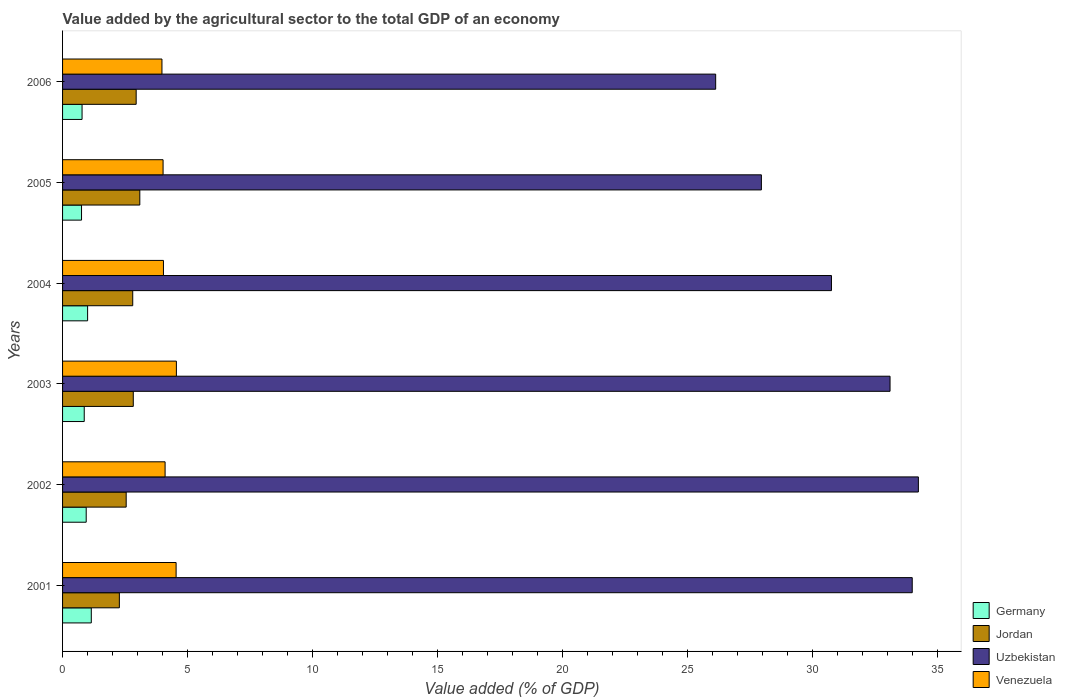How many different coloured bars are there?
Offer a very short reply. 4. Are the number of bars on each tick of the Y-axis equal?
Your answer should be compact. Yes. In how many cases, is the number of bars for a given year not equal to the number of legend labels?
Provide a succinct answer. 0. What is the value added by the agricultural sector to the total GDP in Germany in 2004?
Ensure brevity in your answer.  1. Across all years, what is the maximum value added by the agricultural sector to the total GDP in Jordan?
Make the answer very short. 3.09. Across all years, what is the minimum value added by the agricultural sector to the total GDP in Germany?
Your answer should be compact. 0.76. What is the total value added by the agricultural sector to the total GDP in Uzbekistan in the graph?
Offer a terse response. 186.26. What is the difference between the value added by the agricultural sector to the total GDP in Uzbekistan in 2002 and that in 2004?
Make the answer very short. 3.48. What is the difference between the value added by the agricultural sector to the total GDP in Uzbekistan in 2005 and the value added by the agricultural sector to the total GDP in Germany in 2003?
Offer a very short reply. 27.1. What is the average value added by the agricultural sector to the total GDP in Germany per year?
Your answer should be compact. 0.92. In the year 2004, what is the difference between the value added by the agricultural sector to the total GDP in Jordan and value added by the agricultural sector to the total GDP in Venezuela?
Your answer should be compact. -1.23. What is the ratio of the value added by the agricultural sector to the total GDP in Uzbekistan in 2005 to that in 2006?
Offer a very short reply. 1.07. Is the value added by the agricultural sector to the total GDP in Uzbekistan in 2001 less than that in 2002?
Offer a very short reply. Yes. What is the difference between the highest and the second highest value added by the agricultural sector to the total GDP in Venezuela?
Keep it short and to the point. 0.01. What is the difference between the highest and the lowest value added by the agricultural sector to the total GDP in Germany?
Offer a terse response. 0.39. How many bars are there?
Offer a very short reply. 24. Are all the bars in the graph horizontal?
Offer a terse response. Yes. How many years are there in the graph?
Give a very brief answer. 6. Does the graph contain any zero values?
Your response must be concise. No. Does the graph contain grids?
Your answer should be compact. No. Where does the legend appear in the graph?
Ensure brevity in your answer.  Bottom right. How many legend labels are there?
Provide a short and direct response. 4. How are the legend labels stacked?
Offer a very short reply. Vertical. What is the title of the graph?
Provide a succinct answer. Value added by the agricultural sector to the total GDP of an economy. What is the label or title of the X-axis?
Give a very brief answer. Value added (% of GDP). What is the Value added (% of GDP) of Germany in 2001?
Keep it short and to the point. 1.15. What is the Value added (% of GDP) of Jordan in 2001?
Provide a short and direct response. 2.27. What is the Value added (% of GDP) of Uzbekistan in 2001?
Ensure brevity in your answer.  34.01. What is the Value added (% of GDP) in Venezuela in 2001?
Provide a short and direct response. 4.54. What is the Value added (% of GDP) of Germany in 2002?
Provide a short and direct response. 0.95. What is the Value added (% of GDP) of Jordan in 2002?
Offer a terse response. 2.55. What is the Value added (% of GDP) of Uzbekistan in 2002?
Offer a terse response. 34.25. What is the Value added (% of GDP) in Venezuela in 2002?
Your answer should be very brief. 4.1. What is the Value added (% of GDP) in Germany in 2003?
Keep it short and to the point. 0.87. What is the Value added (% of GDP) of Jordan in 2003?
Your answer should be very brief. 2.83. What is the Value added (% of GDP) of Uzbekistan in 2003?
Ensure brevity in your answer.  33.12. What is the Value added (% of GDP) of Venezuela in 2003?
Your response must be concise. 4.56. What is the Value added (% of GDP) of Germany in 2004?
Provide a succinct answer. 1. What is the Value added (% of GDP) in Jordan in 2004?
Your answer should be very brief. 2.81. What is the Value added (% of GDP) of Uzbekistan in 2004?
Give a very brief answer. 30.77. What is the Value added (% of GDP) of Venezuela in 2004?
Keep it short and to the point. 4.04. What is the Value added (% of GDP) in Germany in 2005?
Provide a short and direct response. 0.76. What is the Value added (% of GDP) of Jordan in 2005?
Provide a short and direct response. 3.09. What is the Value added (% of GDP) in Uzbekistan in 2005?
Your answer should be very brief. 27.97. What is the Value added (% of GDP) of Venezuela in 2005?
Your answer should be very brief. 4.02. What is the Value added (% of GDP) of Germany in 2006?
Offer a terse response. 0.78. What is the Value added (% of GDP) of Jordan in 2006?
Give a very brief answer. 2.95. What is the Value added (% of GDP) in Uzbekistan in 2006?
Offer a terse response. 26.14. What is the Value added (% of GDP) in Venezuela in 2006?
Offer a terse response. 3.98. Across all years, what is the maximum Value added (% of GDP) in Germany?
Your answer should be compact. 1.15. Across all years, what is the maximum Value added (% of GDP) of Jordan?
Offer a terse response. 3.09. Across all years, what is the maximum Value added (% of GDP) of Uzbekistan?
Offer a terse response. 34.25. Across all years, what is the maximum Value added (% of GDP) of Venezuela?
Your answer should be compact. 4.56. Across all years, what is the minimum Value added (% of GDP) of Germany?
Offer a terse response. 0.76. Across all years, what is the minimum Value added (% of GDP) in Jordan?
Provide a short and direct response. 2.27. Across all years, what is the minimum Value added (% of GDP) in Uzbekistan?
Offer a terse response. 26.14. Across all years, what is the minimum Value added (% of GDP) of Venezuela?
Provide a succinct answer. 3.98. What is the total Value added (% of GDP) of Germany in the graph?
Make the answer very short. 5.5. What is the total Value added (% of GDP) in Jordan in the graph?
Provide a succinct answer. 16.5. What is the total Value added (% of GDP) in Uzbekistan in the graph?
Keep it short and to the point. 186.26. What is the total Value added (% of GDP) of Venezuela in the graph?
Provide a succinct answer. 25.24. What is the difference between the Value added (% of GDP) in Germany in 2001 and that in 2002?
Give a very brief answer. 0.2. What is the difference between the Value added (% of GDP) of Jordan in 2001 and that in 2002?
Provide a succinct answer. -0.27. What is the difference between the Value added (% of GDP) in Uzbekistan in 2001 and that in 2002?
Your answer should be compact. -0.25. What is the difference between the Value added (% of GDP) of Venezuela in 2001 and that in 2002?
Your answer should be very brief. 0.44. What is the difference between the Value added (% of GDP) of Germany in 2001 and that in 2003?
Your answer should be very brief. 0.28. What is the difference between the Value added (% of GDP) of Jordan in 2001 and that in 2003?
Provide a short and direct response. -0.56. What is the difference between the Value added (% of GDP) of Uzbekistan in 2001 and that in 2003?
Provide a short and direct response. 0.89. What is the difference between the Value added (% of GDP) of Venezuela in 2001 and that in 2003?
Give a very brief answer. -0.01. What is the difference between the Value added (% of GDP) in Germany in 2001 and that in 2004?
Provide a short and direct response. 0.15. What is the difference between the Value added (% of GDP) of Jordan in 2001 and that in 2004?
Your response must be concise. -0.54. What is the difference between the Value added (% of GDP) of Uzbekistan in 2001 and that in 2004?
Give a very brief answer. 3.23. What is the difference between the Value added (% of GDP) of Venezuela in 2001 and that in 2004?
Your answer should be very brief. 0.51. What is the difference between the Value added (% of GDP) in Germany in 2001 and that in 2005?
Offer a very short reply. 0.39. What is the difference between the Value added (% of GDP) in Jordan in 2001 and that in 2005?
Ensure brevity in your answer.  -0.82. What is the difference between the Value added (% of GDP) in Uzbekistan in 2001 and that in 2005?
Provide a succinct answer. 6.04. What is the difference between the Value added (% of GDP) of Venezuela in 2001 and that in 2005?
Keep it short and to the point. 0.52. What is the difference between the Value added (% of GDP) in Germany in 2001 and that in 2006?
Your response must be concise. 0.37. What is the difference between the Value added (% of GDP) of Jordan in 2001 and that in 2006?
Give a very brief answer. -0.67. What is the difference between the Value added (% of GDP) in Uzbekistan in 2001 and that in 2006?
Provide a short and direct response. 7.87. What is the difference between the Value added (% of GDP) in Venezuela in 2001 and that in 2006?
Your answer should be compact. 0.57. What is the difference between the Value added (% of GDP) of Germany in 2002 and that in 2003?
Your answer should be very brief. 0.08. What is the difference between the Value added (% of GDP) of Jordan in 2002 and that in 2003?
Provide a short and direct response. -0.28. What is the difference between the Value added (% of GDP) of Uzbekistan in 2002 and that in 2003?
Ensure brevity in your answer.  1.13. What is the difference between the Value added (% of GDP) of Venezuela in 2002 and that in 2003?
Your answer should be compact. -0.45. What is the difference between the Value added (% of GDP) of Germany in 2002 and that in 2004?
Provide a succinct answer. -0.06. What is the difference between the Value added (% of GDP) of Jordan in 2002 and that in 2004?
Make the answer very short. -0.26. What is the difference between the Value added (% of GDP) of Uzbekistan in 2002 and that in 2004?
Provide a short and direct response. 3.48. What is the difference between the Value added (% of GDP) of Venezuela in 2002 and that in 2004?
Ensure brevity in your answer.  0.07. What is the difference between the Value added (% of GDP) in Germany in 2002 and that in 2005?
Provide a succinct answer. 0.19. What is the difference between the Value added (% of GDP) in Jordan in 2002 and that in 2005?
Provide a succinct answer. -0.55. What is the difference between the Value added (% of GDP) of Uzbekistan in 2002 and that in 2005?
Provide a succinct answer. 6.28. What is the difference between the Value added (% of GDP) of Venezuela in 2002 and that in 2005?
Give a very brief answer. 0.08. What is the difference between the Value added (% of GDP) of Germany in 2002 and that in 2006?
Your answer should be very brief. 0.17. What is the difference between the Value added (% of GDP) in Jordan in 2002 and that in 2006?
Keep it short and to the point. -0.4. What is the difference between the Value added (% of GDP) of Uzbekistan in 2002 and that in 2006?
Offer a terse response. 8.11. What is the difference between the Value added (% of GDP) of Venezuela in 2002 and that in 2006?
Your answer should be compact. 0.13. What is the difference between the Value added (% of GDP) in Germany in 2003 and that in 2004?
Provide a succinct answer. -0.14. What is the difference between the Value added (% of GDP) in Jordan in 2003 and that in 2004?
Give a very brief answer. 0.02. What is the difference between the Value added (% of GDP) in Uzbekistan in 2003 and that in 2004?
Your response must be concise. 2.34. What is the difference between the Value added (% of GDP) of Venezuela in 2003 and that in 2004?
Keep it short and to the point. 0.52. What is the difference between the Value added (% of GDP) of Germany in 2003 and that in 2005?
Ensure brevity in your answer.  0.11. What is the difference between the Value added (% of GDP) in Jordan in 2003 and that in 2005?
Offer a very short reply. -0.26. What is the difference between the Value added (% of GDP) of Uzbekistan in 2003 and that in 2005?
Ensure brevity in your answer.  5.15. What is the difference between the Value added (% of GDP) in Venezuela in 2003 and that in 2005?
Give a very brief answer. 0.53. What is the difference between the Value added (% of GDP) in Germany in 2003 and that in 2006?
Your answer should be very brief. 0.09. What is the difference between the Value added (% of GDP) of Jordan in 2003 and that in 2006?
Offer a very short reply. -0.12. What is the difference between the Value added (% of GDP) in Uzbekistan in 2003 and that in 2006?
Keep it short and to the point. 6.98. What is the difference between the Value added (% of GDP) of Venezuela in 2003 and that in 2006?
Your response must be concise. 0.58. What is the difference between the Value added (% of GDP) of Germany in 2004 and that in 2005?
Provide a succinct answer. 0.24. What is the difference between the Value added (% of GDP) of Jordan in 2004 and that in 2005?
Give a very brief answer. -0.28. What is the difference between the Value added (% of GDP) of Uzbekistan in 2004 and that in 2005?
Provide a succinct answer. 2.8. What is the difference between the Value added (% of GDP) of Venezuela in 2004 and that in 2005?
Keep it short and to the point. 0.01. What is the difference between the Value added (% of GDP) of Germany in 2004 and that in 2006?
Provide a succinct answer. 0.22. What is the difference between the Value added (% of GDP) of Jordan in 2004 and that in 2006?
Your response must be concise. -0.14. What is the difference between the Value added (% of GDP) in Uzbekistan in 2004 and that in 2006?
Your response must be concise. 4.63. What is the difference between the Value added (% of GDP) in Venezuela in 2004 and that in 2006?
Offer a very short reply. 0.06. What is the difference between the Value added (% of GDP) of Germany in 2005 and that in 2006?
Provide a short and direct response. -0.02. What is the difference between the Value added (% of GDP) of Jordan in 2005 and that in 2006?
Your answer should be very brief. 0.15. What is the difference between the Value added (% of GDP) of Uzbekistan in 2005 and that in 2006?
Offer a terse response. 1.83. What is the difference between the Value added (% of GDP) of Venezuela in 2005 and that in 2006?
Offer a terse response. 0.05. What is the difference between the Value added (% of GDP) of Germany in 2001 and the Value added (% of GDP) of Jordan in 2002?
Keep it short and to the point. -1.4. What is the difference between the Value added (% of GDP) in Germany in 2001 and the Value added (% of GDP) in Uzbekistan in 2002?
Make the answer very short. -33.1. What is the difference between the Value added (% of GDP) of Germany in 2001 and the Value added (% of GDP) of Venezuela in 2002?
Your answer should be very brief. -2.95. What is the difference between the Value added (% of GDP) of Jordan in 2001 and the Value added (% of GDP) of Uzbekistan in 2002?
Your answer should be compact. -31.98. What is the difference between the Value added (% of GDP) of Jordan in 2001 and the Value added (% of GDP) of Venezuela in 2002?
Keep it short and to the point. -1.83. What is the difference between the Value added (% of GDP) of Uzbekistan in 2001 and the Value added (% of GDP) of Venezuela in 2002?
Provide a short and direct response. 29.9. What is the difference between the Value added (% of GDP) in Germany in 2001 and the Value added (% of GDP) in Jordan in 2003?
Make the answer very short. -1.68. What is the difference between the Value added (% of GDP) in Germany in 2001 and the Value added (% of GDP) in Uzbekistan in 2003?
Your response must be concise. -31.97. What is the difference between the Value added (% of GDP) in Germany in 2001 and the Value added (% of GDP) in Venezuela in 2003?
Your answer should be compact. -3.41. What is the difference between the Value added (% of GDP) of Jordan in 2001 and the Value added (% of GDP) of Uzbekistan in 2003?
Provide a succinct answer. -30.84. What is the difference between the Value added (% of GDP) in Jordan in 2001 and the Value added (% of GDP) in Venezuela in 2003?
Make the answer very short. -2.28. What is the difference between the Value added (% of GDP) in Uzbekistan in 2001 and the Value added (% of GDP) in Venezuela in 2003?
Provide a succinct answer. 29.45. What is the difference between the Value added (% of GDP) of Germany in 2001 and the Value added (% of GDP) of Jordan in 2004?
Offer a very short reply. -1.66. What is the difference between the Value added (% of GDP) of Germany in 2001 and the Value added (% of GDP) of Uzbekistan in 2004?
Provide a short and direct response. -29.62. What is the difference between the Value added (% of GDP) of Germany in 2001 and the Value added (% of GDP) of Venezuela in 2004?
Your response must be concise. -2.89. What is the difference between the Value added (% of GDP) of Jordan in 2001 and the Value added (% of GDP) of Uzbekistan in 2004?
Make the answer very short. -28.5. What is the difference between the Value added (% of GDP) of Jordan in 2001 and the Value added (% of GDP) of Venezuela in 2004?
Provide a short and direct response. -1.76. What is the difference between the Value added (% of GDP) of Uzbekistan in 2001 and the Value added (% of GDP) of Venezuela in 2004?
Your answer should be compact. 29.97. What is the difference between the Value added (% of GDP) of Germany in 2001 and the Value added (% of GDP) of Jordan in 2005?
Offer a very short reply. -1.94. What is the difference between the Value added (% of GDP) of Germany in 2001 and the Value added (% of GDP) of Uzbekistan in 2005?
Ensure brevity in your answer.  -26.82. What is the difference between the Value added (% of GDP) of Germany in 2001 and the Value added (% of GDP) of Venezuela in 2005?
Your answer should be very brief. -2.87. What is the difference between the Value added (% of GDP) in Jordan in 2001 and the Value added (% of GDP) in Uzbekistan in 2005?
Make the answer very short. -25.7. What is the difference between the Value added (% of GDP) of Jordan in 2001 and the Value added (% of GDP) of Venezuela in 2005?
Make the answer very short. -1.75. What is the difference between the Value added (% of GDP) in Uzbekistan in 2001 and the Value added (% of GDP) in Venezuela in 2005?
Ensure brevity in your answer.  29.98. What is the difference between the Value added (% of GDP) in Germany in 2001 and the Value added (% of GDP) in Jordan in 2006?
Keep it short and to the point. -1.8. What is the difference between the Value added (% of GDP) in Germany in 2001 and the Value added (% of GDP) in Uzbekistan in 2006?
Make the answer very short. -24.99. What is the difference between the Value added (% of GDP) of Germany in 2001 and the Value added (% of GDP) of Venezuela in 2006?
Provide a succinct answer. -2.83. What is the difference between the Value added (% of GDP) of Jordan in 2001 and the Value added (% of GDP) of Uzbekistan in 2006?
Offer a very short reply. -23.87. What is the difference between the Value added (% of GDP) of Jordan in 2001 and the Value added (% of GDP) of Venezuela in 2006?
Offer a very short reply. -1.7. What is the difference between the Value added (% of GDP) of Uzbekistan in 2001 and the Value added (% of GDP) of Venezuela in 2006?
Offer a very short reply. 30.03. What is the difference between the Value added (% of GDP) in Germany in 2002 and the Value added (% of GDP) in Jordan in 2003?
Your response must be concise. -1.88. What is the difference between the Value added (% of GDP) in Germany in 2002 and the Value added (% of GDP) in Uzbekistan in 2003?
Offer a very short reply. -32.17. What is the difference between the Value added (% of GDP) in Germany in 2002 and the Value added (% of GDP) in Venezuela in 2003?
Provide a short and direct response. -3.61. What is the difference between the Value added (% of GDP) in Jordan in 2002 and the Value added (% of GDP) in Uzbekistan in 2003?
Keep it short and to the point. -30.57. What is the difference between the Value added (% of GDP) in Jordan in 2002 and the Value added (% of GDP) in Venezuela in 2003?
Make the answer very short. -2.01. What is the difference between the Value added (% of GDP) in Uzbekistan in 2002 and the Value added (% of GDP) in Venezuela in 2003?
Give a very brief answer. 29.7. What is the difference between the Value added (% of GDP) in Germany in 2002 and the Value added (% of GDP) in Jordan in 2004?
Provide a succinct answer. -1.86. What is the difference between the Value added (% of GDP) of Germany in 2002 and the Value added (% of GDP) of Uzbekistan in 2004?
Ensure brevity in your answer.  -29.83. What is the difference between the Value added (% of GDP) of Germany in 2002 and the Value added (% of GDP) of Venezuela in 2004?
Your answer should be very brief. -3.09. What is the difference between the Value added (% of GDP) of Jordan in 2002 and the Value added (% of GDP) of Uzbekistan in 2004?
Your answer should be very brief. -28.23. What is the difference between the Value added (% of GDP) in Jordan in 2002 and the Value added (% of GDP) in Venezuela in 2004?
Your answer should be compact. -1.49. What is the difference between the Value added (% of GDP) of Uzbekistan in 2002 and the Value added (% of GDP) of Venezuela in 2004?
Offer a terse response. 30.21. What is the difference between the Value added (% of GDP) of Germany in 2002 and the Value added (% of GDP) of Jordan in 2005?
Keep it short and to the point. -2.15. What is the difference between the Value added (% of GDP) in Germany in 2002 and the Value added (% of GDP) in Uzbekistan in 2005?
Keep it short and to the point. -27.02. What is the difference between the Value added (% of GDP) in Germany in 2002 and the Value added (% of GDP) in Venezuela in 2005?
Your answer should be compact. -3.08. What is the difference between the Value added (% of GDP) of Jordan in 2002 and the Value added (% of GDP) of Uzbekistan in 2005?
Offer a terse response. -25.42. What is the difference between the Value added (% of GDP) of Jordan in 2002 and the Value added (% of GDP) of Venezuela in 2005?
Keep it short and to the point. -1.48. What is the difference between the Value added (% of GDP) of Uzbekistan in 2002 and the Value added (% of GDP) of Venezuela in 2005?
Keep it short and to the point. 30.23. What is the difference between the Value added (% of GDP) of Germany in 2002 and the Value added (% of GDP) of Jordan in 2006?
Offer a very short reply. -2. What is the difference between the Value added (% of GDP) in Germany in 2002 and the Value added (% of GDP) in Uzbekistan in 2006?
Offer a terse response. -25.19. What is the difference between the Value added (% of GDP) in Germany in 2002 and the Value added (% of GDP) in Venezuela in 2006?
Your answer should be very brief. -3.03. What is the difference between the Value added (% of GDP) in Jordan in 2002 and the Value added (% of GDP) in Uzbekistan in 2006?
Provide a short and direct response. -23.59. What is the difference between the Value added (% of GDP) of Jordan in 2002 and the Value added (% of GDP) of Venezuela in 2006?
Ensure brevity in your answer.  -1.43. What is the difference between the Value added (% of GDP) of Uzbekistan in 2002 and the Value added (% of GDP) of Venezuela in 2006?
Keep it short and to the point. 30.27. What is the difference between the Value added (% of GDP) of Germany in 2003 and the Value added (% of GDP) of Jordan in 2004?
Make the answer very short. -1.94. What is the difference between the Value added (% of GDP) in Germany in 2003 and the Value added (% of GDP) in Uzbekistan in 2004?
Provide a short and direct response. -29.91. What is the difference between the Value added (% of GDP) of Germany in 2003 and the Value added (% of GDP) of Venezuela in 2004?
Provide a short and direct response. -3.17. What is the difference between the Value added (% of GDP) of Jordan in 2003 and the Value added (% of GDP) of Uzbekistan in 2004?
Offer a very short reply. -27.94. What is the difference between the Value added (% of GDP) of Jordan in 2003 and the Value added (% of GDP) of Venezuela in 2004?
Offer a very short reply. -1.21. What is the difference between the Value added (% of GDP) of Uzbekistan in 2003 and the Value added (% of GDP) of Venezuela in 2004?
Provide a short and direct response. 29.08. What is the difference between the Value added (% of GDP) of Germany in 2003 and the Value added (% of GDP) of Jordan in 2005?
Your answer should be compact. -2.22. What is the difference between the Value added (% of GDP) in Germany in 2003 and the Value added (% of GDP) in Uzbekistan in 2005?
Offer a terse response. -27.1. What is the difference between the Value added (% of GDP) of Germany in 2003 and the Value added (% of GDP) of Venezuela in 2005?
Provide a short and direct response. -3.16. What is the difference between the Value added (% of GDP) in Jordan in 2003 and the Value added (% of GDP) in Uzbekistan in 2005?
Provide a short and direct response. -25.14. What is the difference between the Value added (% of GDP) in Jordan in 2003 and the Value added (% of GDP) in Venezuela in 2005?
Your answer should be compact. -1.19. What is the difference between the Value added (% of GDP) in Uzbekistan in 2003 and the Value added (% of GDP) in Venezuela in 2005?
Offer a terse response. 29.09. What is the difference between the Value added (% of GDP) of Germany in 2003 and the Value added (% of GDP) of Jordan in 2006?
Keep it short and to the point. -2.08. What is the difference between the Value added (% of GDP) in Germany in 2003 and the Value added (% of GDP) in Uzbekistan in 2006?
Make the answer very short. -25.27. What is the difference between the Value added (% of GDP) in Germany in 2003 and the Value added (% of GDP) in Venezuela in 2006?
Provide a short and direct response. -3.11. What is the difference between the Value added (% of GDP) of Jordan in 2003 and the Value added (% of GDP) of Uzbekistan in 2006?
Your response must be concise. -23.31. What is the difference between the Value added (% of GDP) of Jordan in 2003 and the Value added (% of GDP) of Venezuela in 2006?
Provide a succinct answer. -1.15. What is the difference between the Value added (% of GDP) of Uzbekistan in 2003 and the Value added (% of GDP) of Venezuela in 2006?
Give a very brief answer. 29.14. What is the difference between the Value added (% of GDP) of Germany in 2004 and the Value added (% of GDP) of Jordan in 2005?
Give a very brief answer. -2.09. What is the difference between the Value added (% of GDP) in Germany in 2004 and the Value added (% of GDP) in Uzbekistan in 2005?
Your answer should be compact. -26.97. What is the difference between the Value added (% of GDP) in Germany in 2004 and the Value added (% of GDP) in Venezuela in 2005?
Ensure brevity in your answer.  -3.02. What is the difference between the Value added (% of GDP) of Jordan in 2004 and the Value added (% of GDP) of Uzbekistan in 2005?
Provide a short and direct response. -25.16. What is the difference between the Value added (% of GDP) in Jordan in 2004 and the Value added (% of GDP) in Venezuela in 2005?
Make the answer very short. -1.21. What is the difference between the Value added (% of GDP) in Uzbekistan in 2004 and the Value added (% of GDP) in Venezuela in 2005?
Your answer should be very brief. 26.75. What is the difference between the Value added (% of GDP) of Germany in 2004 and the Value added (% of GDP) of Jordan in 2006?
Your response must be concise. -1.94. What is the difference between the Value added (% of GDP) in Germany in 2004 and the Value added (% of GDP) in Uzbekistan in 2006?
Provide a short and direct response. -25.14. What is the difference between the Value added (% of GDP) in Germany in 2004 and the Value added (% of GDP) in Venezuela in 2006?
Offer a terse response. -2.98. What is the difference between the Value added (% of GDP) of Jordan in 2004 and the Value added (% of GDP) of Uzbekistan in 2006?
Give a very brief answer. -23.33. What is the difference between the Value added (% of GDP) in Jordan in 2004 and the Value added (% of GDP) in Venezuela in 2006?
Your answer should be compact. -1.17. What is the difference between the Value added (% of GDP) in Uzbekistan in 2004 and the Value added (% of GDP) in Venezuela in 2006?
Provide a short and direct response. 26.8. What is the difference between the Value added (% of GDP) in Germany in 2005 and the Value added (% of GDP) in Jordan in 2006?
Ensure brevity in your answer.  -2.19. What is the difference between the Value added (% of GDP) in Germany in 2005 and the Value added (% of GDP) in Uzbekistan in 2006?
Your answer should be compact. -25.38. What is the difference between the Value added (% of GDP) of Germany in 2005 and the Value added (% of GDP) of Venezuela in 2006?
Keep it short and to the point. -3.22. What is the difference between the Value added (% of GDP) in Jordan in 2005 and the Value added (% of GDP) in Uzbekistan in 2006?
Give a very brief answer. -23.05. What is the difference between the Value added (% of GDP) in Jordan in 2005 and the Value added (% of GDP) in Venezuela in 2006?
Provide a succinct answer. -0.89. What is the difference between the Value added (% of GDP) in Uzbekistan in 2005 and the Value added (% of GDP) in Venezuela in 2006?
Make the answer very short. 23.99. What is the average Value added (% of GDP) in Germany per year?
Provide a succinct answer. 0.92. What is the average Value added (% of GDP) of Jordan per year?
Your answer should be very brief. 2.75. What is the average Value added (% of GDP) of Uzbekistan per year?
Your response must be concise. 31.04. What is the average Value added (% of GDP) in Venezuela per year?
Make the answer very short. 4.21. In the year 2001, what is the difference between the Value added (% of GDP) in Germany and Value added (% of GDP) in Jordan?
Ensure brevity in your answer.  -1.12. In the year 2001, what is the difference between the Value added (% of GDP) in Germany and Value added (% of GDP) in Uzbekistan?
Make the answer very short. -32.86. In the year 2001, what is the difference between the Value added (% of GDP) in Germany and Value added (% of GDP) in Venezuela?
Provide a succinct answer. -3.39. In the year 2001, what is the difference between the Value added (% of GDP) in Jordan and Value added (% of GDP) in Uzbekistan?
Keep it short and to the point. -31.73. In the year 2001, what is the difference between the Value added (% of GDP) of Jordan and Value added (% of GDP) of Venezuela?
Your response must be concise. -2.27. In the year 2001, what is the difference between the Value added (% of GDP) in Uzbekistan and Value added (% of GDP) in Venezuela?
Your answer should be very brief. 29.46. In the year 2002, what is the difference between the Value added (% of GDP) of Germany and Value added (% of GDP) of Jordan?
Make the answer very short. -1.6. In the year 2002, what is the difference between the Value added (% of GDP) of Germany and Value added (% of GDP) of Uzbekistan?
Offer a terse response. -33.31. In the year 2002, what is the difference between the Value added (% of GDP) in Germany and Value added (% of GDP) in Venezuela?
Your answer should be compact. -3.16. In the year 2002, what is the difference between the Value added (% of GDP) in Jordan and Value added (% of GDP) in Uzbekistan?
Your answer should be very brief. -31.71. In the year 2002, what is the difference between the Value added (% of GDP) in Jordan and Value added (% of GDP) in Venezuela?
Keep it short and to the point. -1.56. In the year 2002, what is the difference between the Value added (% of GDP) in Uzbekistan and Value added (% of GDP) in Venezuela?
Make the answer very short. 30.15. In the year 2003, what is the difference between the Value added (% of GDP) of Germany and Value added (% of GDP) of Jordan?
Your answer should be very brief. -1.96. In the year 2003, what is the difference between the Value added (% of GDP) of Germany and Value added (% of GDP) of Uzbekistan?
Provide a short and direct response. -32.25. In the year 2003, what is the difference between the Value added (% of GDP) in Germany and Value added (% of GDP) in Venezuela?
Ensure brevity in your answer.  -3.69. In the year 2003, what is the difference between the Value added (% of GDP) in Jordan and Value added (% of GDP) in Uzbekistan?
Ensure brevity in your answer.  -30.29. In the year 2003, what is the difference between the Value added (% of GDP) of Jordan and Value added (% of GDP) of Venezuela?
Offer a very short reply. -1.73. In the year 2003, what is the difference between the Value added (% of GDP) in Uzbekistan and Value added (% of GDP) in Venezuela?
Your answer should be very brief. 28.56. In the year 2004, what is the difference between the Value added (% of GDP) in Germany and Value added (% of GDP) in Jordan?
Ensure brevity in your answer.  -1.81. In the year 2004, what is the difference between the Value added (% of GDP) of Germany and Value added (% of GDP) of Uzbekistan?
Make the answer very short. -29.77. In the year 2004, what is the difference between the Value added (% of GDP) in Germany and Value added (% of GDP) in Venezuela?
Offer a very short reply. -3.04. In the year 2004, what is the difference between the Value added (% of GDP) in Jordan and Value added (% of GDP) in Uzbekistan?
Ensure brevity in your answer.  -27.96. In the year 2004, what is the difference between the Value added (% of GDP) in Jordan and Value added (% of GDP) in Venezuela?
Your answer should be very brief. -1.23. In the year 2004, what is the difference between the Value added (% of GDP) in Uzbekistan and Value added (% of GDP) in Venezuela?
Your response must be concise. 26.74. In the year 2005, what is the difference between the Value added (% of GDP) of Germany and Value added (% of GDP) of Jordan?
Your answer should be compact. -2.33. In the year 2005, what is the difference between the Value added (% of GDP) of Germany and Value added (% of GDP) of Uzbekistan?
Keep it short and to the point. -27.21. In the year 2005, what is the difference between the Value added (% of GDP) of Germany and Value added (% of GDP) of Venezuela?
Your answer should be compact. -3.26. In the year 2005, what is the difference between the Value added (% of GDP) in Jordan and Value added (% of GDP) in Uzbekistan?
Offer a terse response. -24.88. In the year 2005, what is the difference between the Value added (% of GDP) of Jordan and Value added (% of GDP) of Venezuela?
Make the answer very short. -0.93. In the year 2005, what is the difference between the Value added (% of GDP) in Uzbekistan and Value added (% of GDP) in Venezuela?
Offer a very short reply. 23.95. In the year 2006, what is the difference between the Value added (% of GDP) of Germany and Value added (% of GDP) of Jordan?
Offer a terse response. -2.17. In the year 2006, what is the difference between the Value added (% of GDP) in Germany and Value added (% of GDP) in Uzbekistan?
Ensure brevity in your answer.  -25.36. In the year 2006, what is the difference between the Value added (% of GDP) of Germany and Value added (% of GDP) of Venezuela?
Provide a short and direct response. -3.2. In the year 2006, what is the difference between the Value added (% of GDP) of Jordan and Value added (% of GDP) of Uzbekistan?
Keep it short and to the point. -23.19. In the year 2006, what is the difference between the Value added (% of GDP) of Jordan and Value added (% of GDP) of Venezuela?
Your answer should be compact. -1.03. In the year 2006, what is the difference between the Value added (% of GDP) in Uzbekistan and Value added (% of GDP) in Venezuela?
Your response must be concise. 22.16. What is the ratio of the Value added (% of GDP) in Germany in 2001 to that in 2002?
Provide a short and direct response. 1.22. What is the ratio of the Value added (% of GDP) of Jordan in 2001 to that in 2002?
Ensure brevity in your answer.  0.89. What is the ratio of the Value added (% of GDP) of Venezuela in 2001 to that in 2002?
Keep it short and to the point. 1.11. What is the ratio of the Value added (% of GDP) in Germany in 2001 to that in 2003?
Provide a succinct answer. 1.33. What is the ratio of the Value added (% of GDP) in Jordan in 2001 to that in 2003?
Keep it short and to the point. 0.8. What is the ratio of the Value added (% of GDP) of Uzbekistan in 2001 to that in 2003?
Provide a short and direct response. 1.03. What is the ratio of the Value added (% of GDP) in Venezuela in 2001 to that in 2003?
Your response must be concise. 1. What is the ratio of the Value added (% of GDP) of Germany in 2001 to that in 2004?
Give a very brief answer. 1.15. What is the ratio of the Value added (% of GDP) of Jordan in 2001 to that in 2004?
Your response must be concise. 0.81. What is the ratio of the Value added (% of GDP) of Uzbekistan in 2001 to that in 2004?
Provide a succinct answer. 1.1. What is the ratio of the Value added (% of GDP) of Venezuela in 2001 to that in 2004?
Make the answer very short. 1.13. What is the ratio of the Value added (% of GDP) in Germany in 2001 to that in 2005?
Offer a terse response. 1.52. What is the ratio of the Value added (% of GDP) of Jordan in 2001 to that in 2005?
Ensure brevity in your answer.  0.74. What is the ratio of the Value added (% of GDP) of Uzbekistan in 2001 to that in 2005?
Give a very brief answer. 1.22. What is the ratio of the Value added (% of GDP) in Venezuela in 2001 to that in 2005?
Offer a very short reply. 1.13. What is the ratio of the Value added (% of GDP) of Germany in 2001 to that in 2006?
Provide a succinct answer. 1.47. What is the ratio of the Value added (% of GDP) in Jordan in 2001 to that in 2006?
Give a very brief answer. 0.77. What is the ratio of the Value added (% of GDP) in Uzbekistan in 2001 to that in 2006?
Make the answer very short. 1.3. What is the ratio of the Value added (% of GDP) in Venezuela in 2001 to that in 2006?
Give a very brief answer. 1.14. What is the ratio of the Value added (% of GDP) of Germany in 2002 to that in 2003?
Offer a very short reply. 1.09. What is the ratio of the Value added (% of GDP) in Jordan in 2002 to that in 2003?
Give a very brief answer. 0.9. What is the ratio of the Value added (% of GDP) in Uzbekistan in 2002 to that in 2003?
Give a very brief answer. 1.03. What is the ratio of the Value added (% of GDP) in Venezuela in 2002 to that in 2003?
Offer a terse response. 0.9. What is the ratio of the Value added (% of GDP) of Germany in 2002 to that in 2004?
Your answer should be compact. 0.94. What is the ratio of the Value added (% of GDP) of Jordan in 2002 to that in 2004?
Your answer should be compact. 0.91. What is the ratio of the Value added (% of GDP) in Uzbekistan in 2002 to that in 2004?
Provide a succinct answer. 1.11. What is the ratio of the Value added (% of GDP) of Venezuela in 2002 to that in 2004?
Give a very brief answer. 1.02. What is the ratio of the Value added (% of GDP) in Germany in 2002 to that in 2005?
Make the answer very short. 1.25. What is the ratio of the Value added (% of GDP) of Jordan in 2002 to that in 2005?
Provide a short and direct response. 0.82. What is the ratio of the Value added (% of GDP) of Uzbekistan in 2002 to that in 2005?
Provide a succinct answer. 1.22. What is the ratio of the Value added (% of GDP) of Germany in 2002 to that in 2006?
Your answer should be compact. 1.21. What is the ratio of the Value added (% of GDP) of Jordan in 2002 to that in 2006?
Your answer should be very brief. 0.86. What is the ratio of the Value added (% of GDP) of Uzbekistan in 2002 to that in 2006?
Your response must be concise. 1.31. What is the ratio of the Value added (% of GDP) in Venezuela in 2002 to that in 2006?
Give a very brief answer. 1.03. What is the ratio of the Value added (% of GDP) in Germany in 2003 to that in 2004?
Offer a very short reply. 0.87. What is the ratio of the Value added (% of GDP) in Jordan in 2003 to that in 2004?
Ensure brevity in your answer.  1.01. What is the ratio of the Value added (% of GDP) in Uzbekistan in 2003 to that in 2004?
Your answer should be compact. 1.08. What is the ratio of the Value added (% of GDP) of Venezuela in 2003 to that in 2004?
Your answer should be compact. 1.13. What is the ratio of the Value added (% of GDP) of Germany in 2003 to that in 2005?
Keep it short and to the point. 1.14. What is the ratio of the Value added (% of GDP) of Jordan in 2003 to that in 2005?
Offer a terse response. 0.92. What is the ratio of the Value added (% of GDP) in Uzbekistan in 2003 to that in 2005?
Your answer should be very brief. 1.18. What is the ratio of the Value added (% of GDP) of Venezuela in 2003 to that in 2005?
Your response must be concise. 1.13. What is the ratio of the Value added (% of GDP) of Germany in 2003 to that in 2006?
Your response must be concise. 1.11. What is the ratio of the Value added (% of GDP) of Jordan in 2003 to that in 2006?
Your answer should be compact. 0.96. What is the ratio of the Value added (% of GDP) of Uzbekistan in 2003 to that in 2006?
Offer a terse response. 1.27. What is the ratio of the Value added (% of GDP) in Venezuela in 2003 to that in 2006?
Your response must be concise. 1.15. What is the ratio of the Value added (% of GDP) in Germany in 2004 to that in 2005?
Offer a terse response. 1.32. What is the ratio of the Value added (% of GDP) in Jordan in 2004 to that in 2005?
Offer a terse response. 0.91. What is the ratio of the Value added (% of GDP) of Uzbekistan in 2004 to that in 2005?
Give a very brief answer. 1.1. What is the ratio of the Value added (% of GDP) in Germany in 2004 to that in 2006?
Make the answer very short. 1.28. What is the ratio of the Value added (% of GDP) of Jordan in 2004 to that in 2006?
Your answer should be compact. 0.95. What is the ratio of the Value added (% of GDP) of Uzbekistan in 2004 to that in 2006?
Provide a short and direct response. 1.18. What is the ratio of the Value added (% of GDP) of Venezuela in 2004 to that in 2006?
Offer a terse response. 1.01. What is the ratio of the Value added (% of GDP) in Germany in 2005 to that in 2006?
Offer a very short reply. 0.97. What is the ratio of the Value added (% of GDP) in Jordan in 2005 to that in 2006?
Make the answer very short. 1.05. What is the ratio of the Value added (% of GDP) of Uzbekistan in 2005 to that in 2006?
Give a very brief answer. 1.07. What is the ratio of the Value added (% of GDP) of Venezuela in 2005 to that in 2006?
Ensure brevity in your answer.  1.01. What is the difference between the highest and the second highest Value added (% of GDP) of Germany?
Ensure brevity in your answer.  0.15. What is the difference between the highest and the second highest Value added (% of GDP) in Jordan?
Offer a very short reply. 0.15. What is the difference between the highest and the second highest Value added (% of GDP) of Uzbekistan?
Your response must be concise. 0.25. What is the difference between the highest and the second highest Value added (% of GDP) in Venezuela?
Your response must be concise. 0.01. What is the difference between the highest and the lowest Value added (% of GDP) of Germany?
Make the answer very short. 0.39. What is the difference between the highest and the lowest Value added (% of GDP) in Jordan?
Give a very brief answer. 0.82. What is the difference between the highest and the lowest Value added (% of GDP) of Uzbekistan?
Your response must be concise. 8.11. What is the difference between the highest and the lowest Value added (% of GDP) in Venezuela?
Your answer should be very brief. 0.58. 